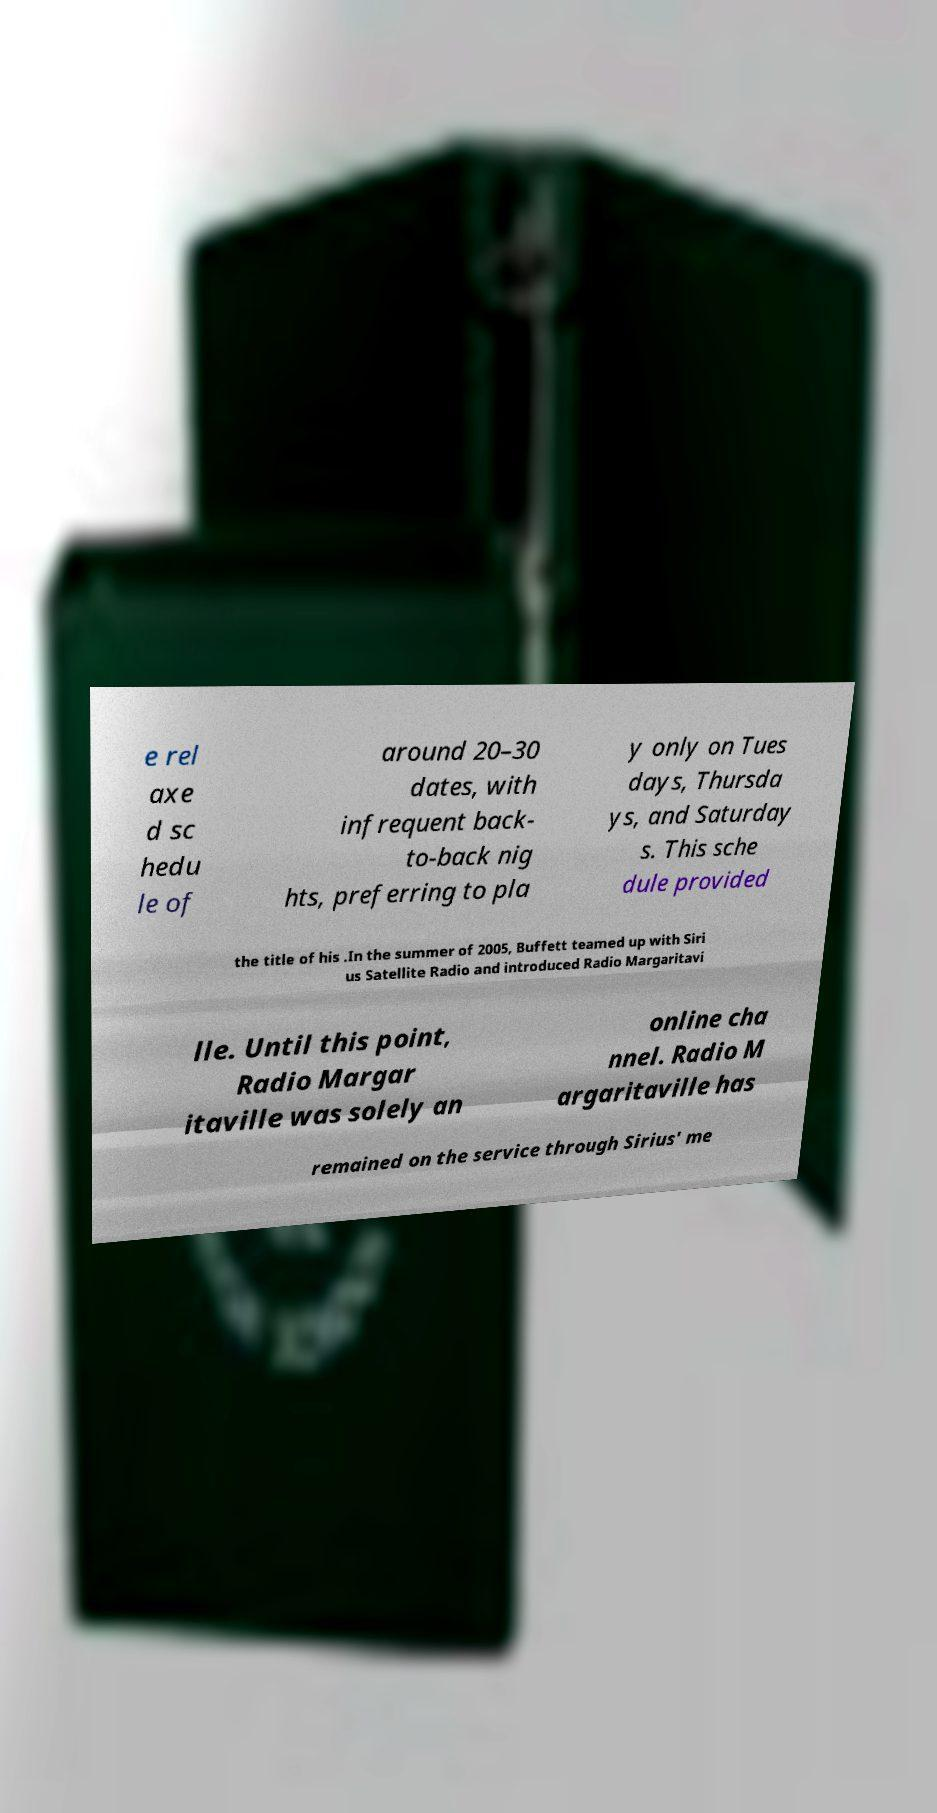Can you read and provide the text displayed in the image?This photo seems to have some interesting text. Can you extract and type it out for me? e rel axe d sc hedu le of around 20–30 dates, with infrequent back- to-back nig hts, preferring to pla y only on Tues days, Thursda ys, and Saturday s. This sche dule provided the title of his .In the summer of 2005, Buffett teamed up with Siri us Satellite Radio and introduced Radio Margaritavi lle. Until this point, Radio Margar itaville was solely an online cha nnel. Radio M argaritaville has remained on the service through Sirius' me 